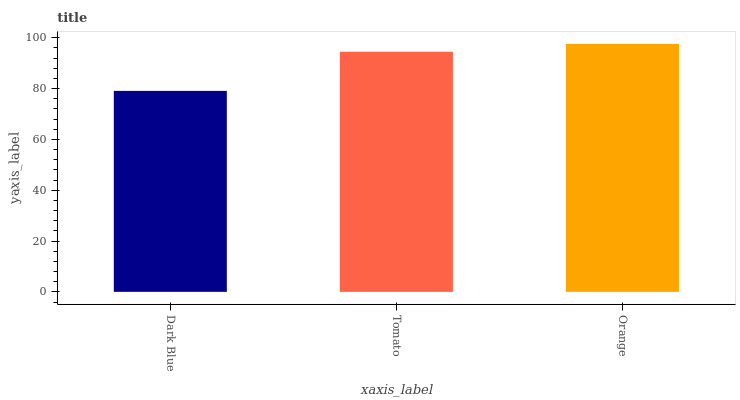Is Dark Blue the minimum?
Answer yes or no. Yes. Is Orange the maximum?
Answer yes or no. Yes. Is Tomato the minimum?
Answer yes or no. No. Is Tomato the maximum?
Answer yes or no. No. Is Tomato greater than Dark Blue?
Answer yes or no. Yes. Is Dark Blue less than Tomato?
Answer yes or no. Yes. Is Dark Blue greater than Tomato?
Answer yes or no. No. Is Tomato less than Dark Blue?
Answer yes or no. No. Is Tomato the high median?
Answer yes or no. Yes. Is Tomato the low median?
Answer yes or no. Yes. Is Orange the high median?
Answer yes or no. No. Is Dark Blue the low median?
Answer yes or no. No. 